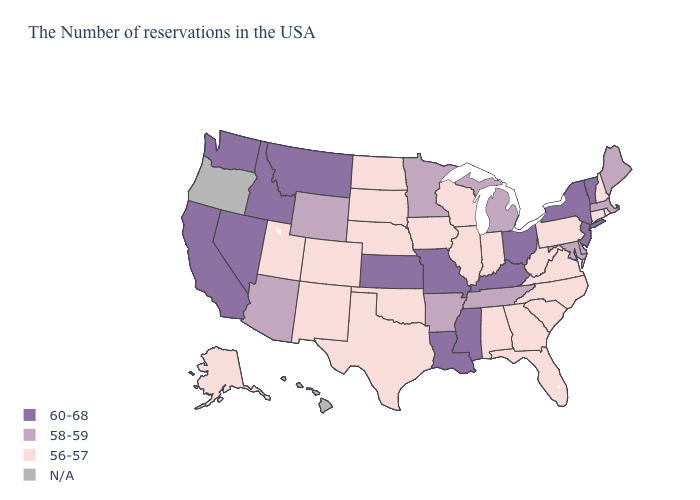Does Arizona have the highest value in the USA?
Short answer required. No. Which states hav the highest value in the West?
Keep it brief. Montana, Idaho, Nevada, California, Washington. What is the highest value in states that border Vermont?
Give a very brief answer. 60-68. What is the value of South Dakota?
Keep it brief. 56-57. What is the lowest value in the USA?
Give a very brief answer. 56-57. How many symbols are there in the legend?
Give a very brief answer. 4. What is the value of Oklahoma?
Answer briefly. 56-57. What is the lowest value in the West?
Answer briefly. 56-57. What is the value of California?
Keep it brief. 60-68. Does the first symbol in the legend represent the smallest category?
Concise answer only. No. What is the value of Tennessee?
Give a very brief answer. 58-59. Which states have the lowest value in the MidWest?
Write a very short answer. Indiana, Wisconsin, Illinois, Iowa, Nebraska, South Dakota, North Dakota. Among the states that border New Jersey , which have the highest value?
Write a very short answer. New York. Among the states that border Utah , does New Mexico have the lowest value?
Be succinct. Yes. 